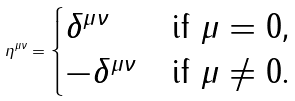<formula> <loc_0><loc_0><loc_500><loc_500>\eta ^ { \mu \nu } = \begin{cases} \delta ^ { \mu \nu } & \text {if $\mu=0$,} \\ - \delta ^ { \mu \nu } & \text {if $\mu\neq 0$.} \end{cases}</formula> 